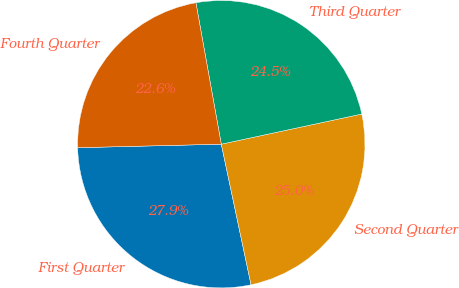<chart> <loc_0><loc_0><loc_500><loc_500><pie_chart><fcel>First Quarter<fcel>Second Quarter<fcel>Third Quarter<fcel>Fourth Quarter<nl><fcel>27.93%<fcel>25.04%<fcel>24.46%<fcel>22.56%<nl></chart> 